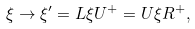<formula> <loc_0><loc_0><loc_500><loc_500>\xi \to \xi ^ { \prime } = L \xi U ^ { + } = U \xi R ^ { + } ,</formula> 